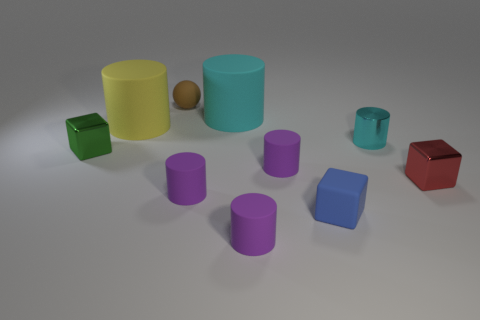Subtract all yellow blocks. How many purple cylinders are left? 3 Subtract 1 cylinders. How many cylinders are left? 5 Subtract all yellow cylinders. How many cylinders are left? 5 Subtract all big yellow matte cylinders. How many cylinders are left? 5 Subtract all brown cylinders. Subtract all green balls. How many cylinders are left? 6 Subtract all cubes. How many objects are left? 7 Add 1 rubber cylinders. How many rubber cylinders are left? 6 Add 6 small brown rubber spheres. How many small brown rubber spheres exist? 7 Subtract 0 blue cylinders. How many objects are left? 10 Subtract all green matte cylinders. Subtract all large objects. How many objects are left? 8 